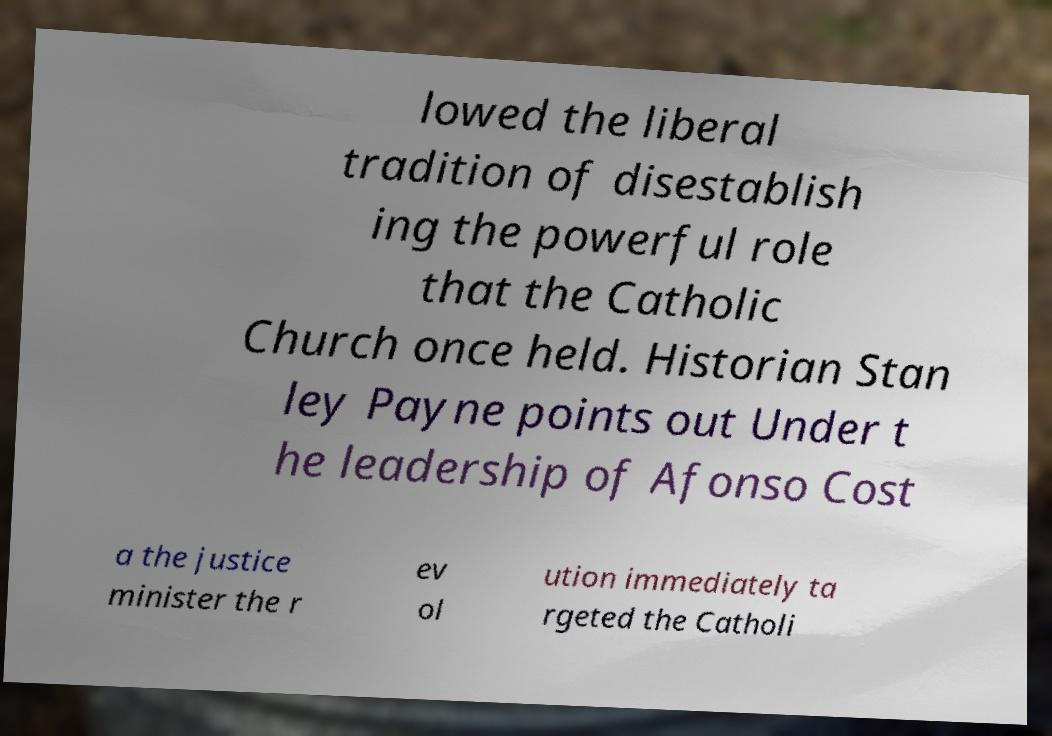Please read and relay the text visible in this image. What does it say? lowed the liberal tradition of disestablish ing the powerful role that the Catholic Church once held. Historian Stan ley Payne points out Under t he leadership of Afonso Cost a the justice minister the r ev ol ution immediately ta rgeted the Catholi 